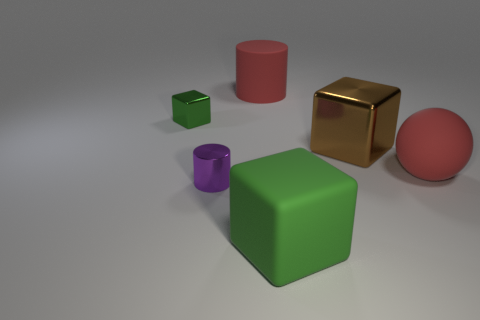Subtract all tiny cubes. How many cubes are left? 2 Subtract all cyan cylinders. How many green cubes are left? 2 Add 2 tiny red things. How many objects exist? 8 Subtract all green cubes. How many cubes are left? 1 Subtract 1 blocks. How many blocks are left? 2 Add 4 green balls. How many green balls exist? 4 Subtract 0 green cylinders. How many objects are left? 6 Subtract all spheres. How many objects are left? 5 Subtract all brown cubes. Subtract all brown cylinders. How many cubes are left? 2 Subtract all large blocks. Subtract all brown objects. How many objects are left? 3 